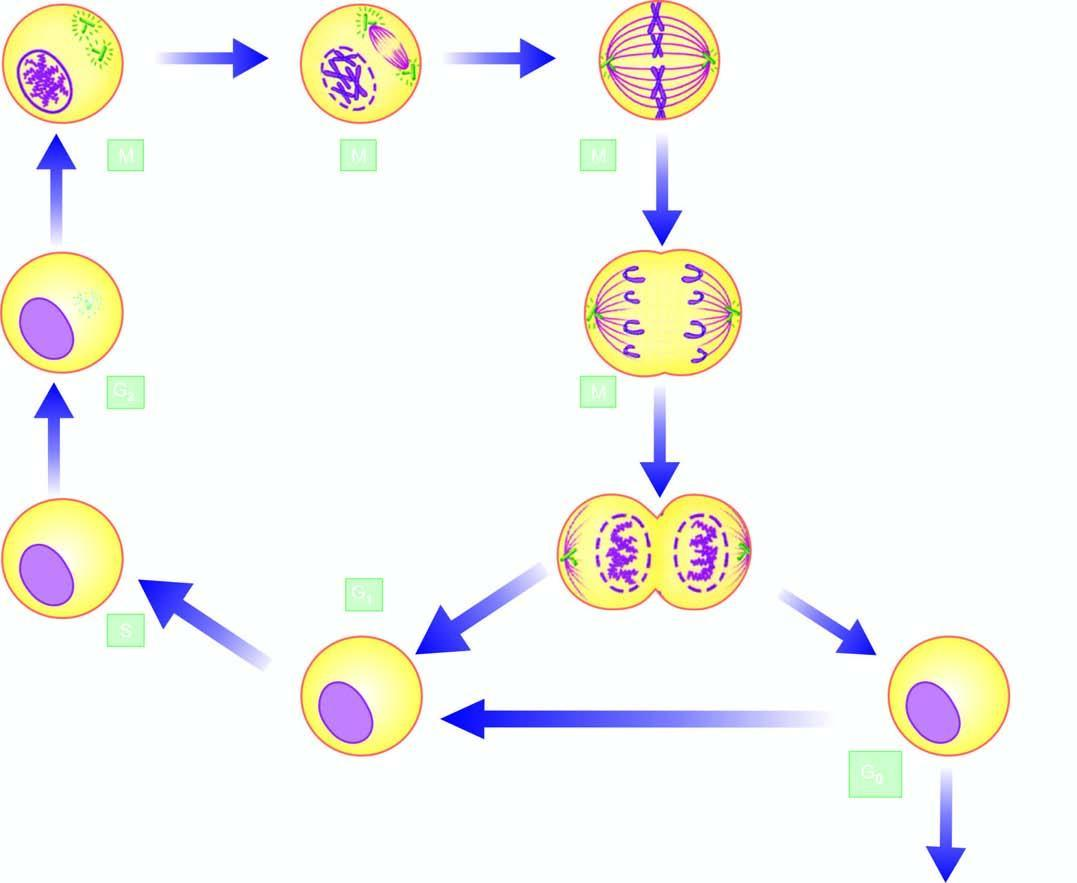how many phases are in premitotic phases?
Answer the question using a single word or phrase. 4 